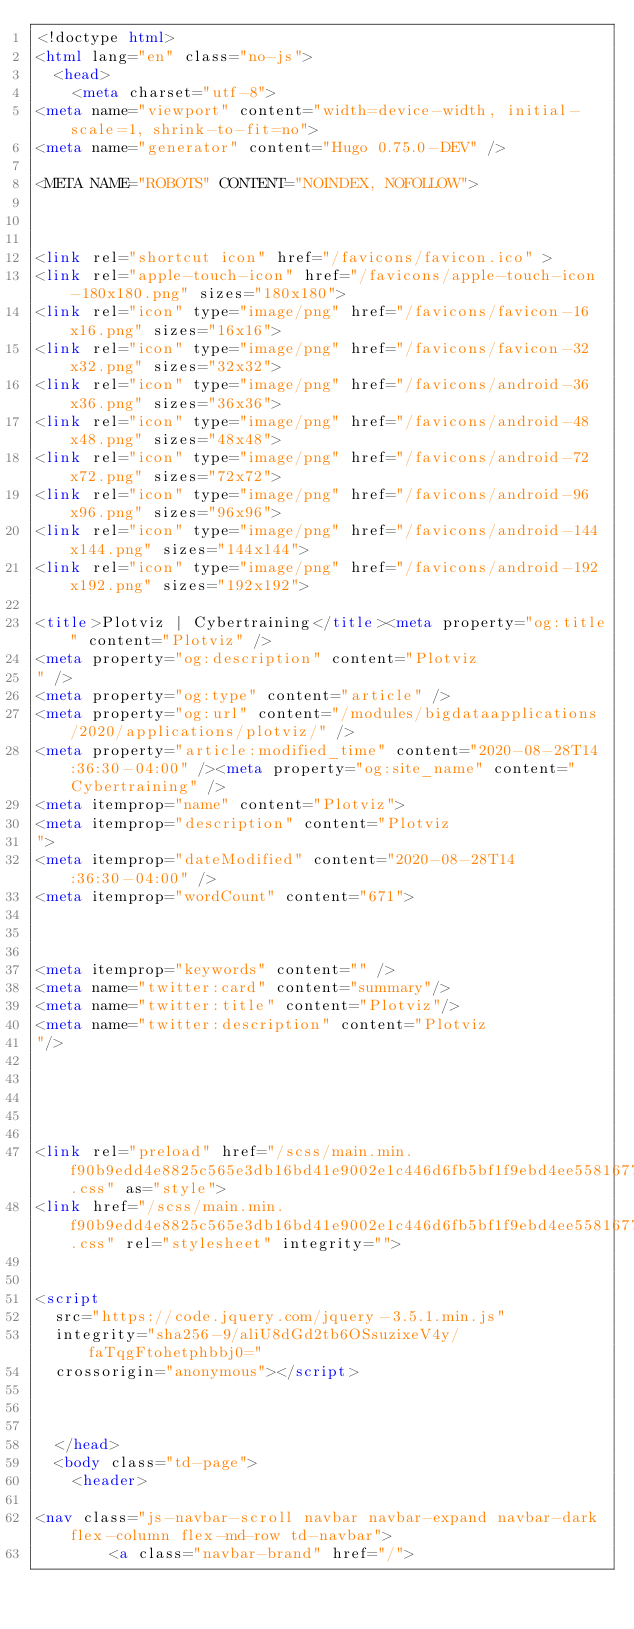<code> <loc_0><loc_0><loc_500><loc_500><_HTML_><!doctype html>
<html lang="en" class="no-js">
  <head>
    <meta charset="utf-8">
<meta name="viewport" content="width=device-width, initial-scale=1, shrink-to-fit=no">
<meta name="generator" content="Hugo 0.75.0-DEV" />

<META NAME="ROBOTS" CONTENT="NOINDEX, NOFOLLOW">



<link rel="shortcut icon" href="/favicons/favicon.ico" >
<link rel="apple-touch-icon" href="/favicons/apple-touch-icon-180x180.png" sizes="180x180">
<link rel="icon" type="image/png" href="/favicons/favicon-16x16.png" sizes="16x16">
<link rel="icon" type="image/png" href="/favicons/favicon-32x32.png" sizes="32x32">
<link rel="icon" type="image/png" href="/favicons/android-36x36.png" sizes="36x36">
<link rel="icon" type="image/png" href="/favicons/android-48x48.png" sizes="48x48">
<link rel="icon" type="image/png" href="/favicons/android-72x72.png" sizes="72x72">
<link rel="icon" type="image/png" href="/favicons/android-96x96.png" sizes="96x96">
<link rel="icon" type="image/png" href="/favicons/android-144x144.png" sizes="144x144">
<link rel="icon" type="image/png" href="/favicons/android-192x192.png" sizes="192x192">

<title>Plotviz | Cybertraining</title><meta property="og:title" content="Plotviz" />
<meta property="og:description" content="Plotviz
" />
<meta property="og:type" content="article" />
<meta property="og:url" content="/modules/bigdataapplications/2020/applications/plotviz/" />
<meta property="article:modified_time" content="2020-08-28T14:36:30-04:00" /><meta property="og:site_name" content="Cybertraining" />
<meta itemprop="name" content="Plotviz">
<meta itemprop="description" content="Plotviz
">
<meta itemprop="dateModified" content="2020-08-28T14:36:30-04:00" />
<meta itemprop="wordCount" content="671">



<meta itemprop="keywords" content="" />
<meta name="twitter:card" content="summary"/>
<meta name="twitter:title" content="Plotviz"/>
<meta name="twitter:description" content="Plotviz
"/>





<link rel="preload" href="/scss/main.min.f90b9edd4e8825c565e3db16bd41e9002e1c446d6fb5bf1f9ebd4ee5581677a6.css" as="style">
<link href="/scss/main.min.f90b9edd4e8825c565e3db16bd41e9002e1c446d6fb5bf1f9ebd4ee5581677a6.css" rel="stylesheet" integrity="">


<script
  src="https://code.jquery.com/jquery-3.5.1.min.js"
  integrity="sha256-9/aliU8dGd2tb6OSsuzixeV4y/faTqgFtohetphbbj0="
  crossorigin="anonymous"></script>



  </head>
  <body class="td-page">
    <header>
      
<nav class="js-navbar-scroll navbar navbar-expand navbar-dark flex-column flex-md-row td-navbar">
        <a class="navbar-brand" href="/"></code> 